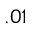<formula> <loc_0><loc_0><loc_500><loc_500>. 0 1</formula> 